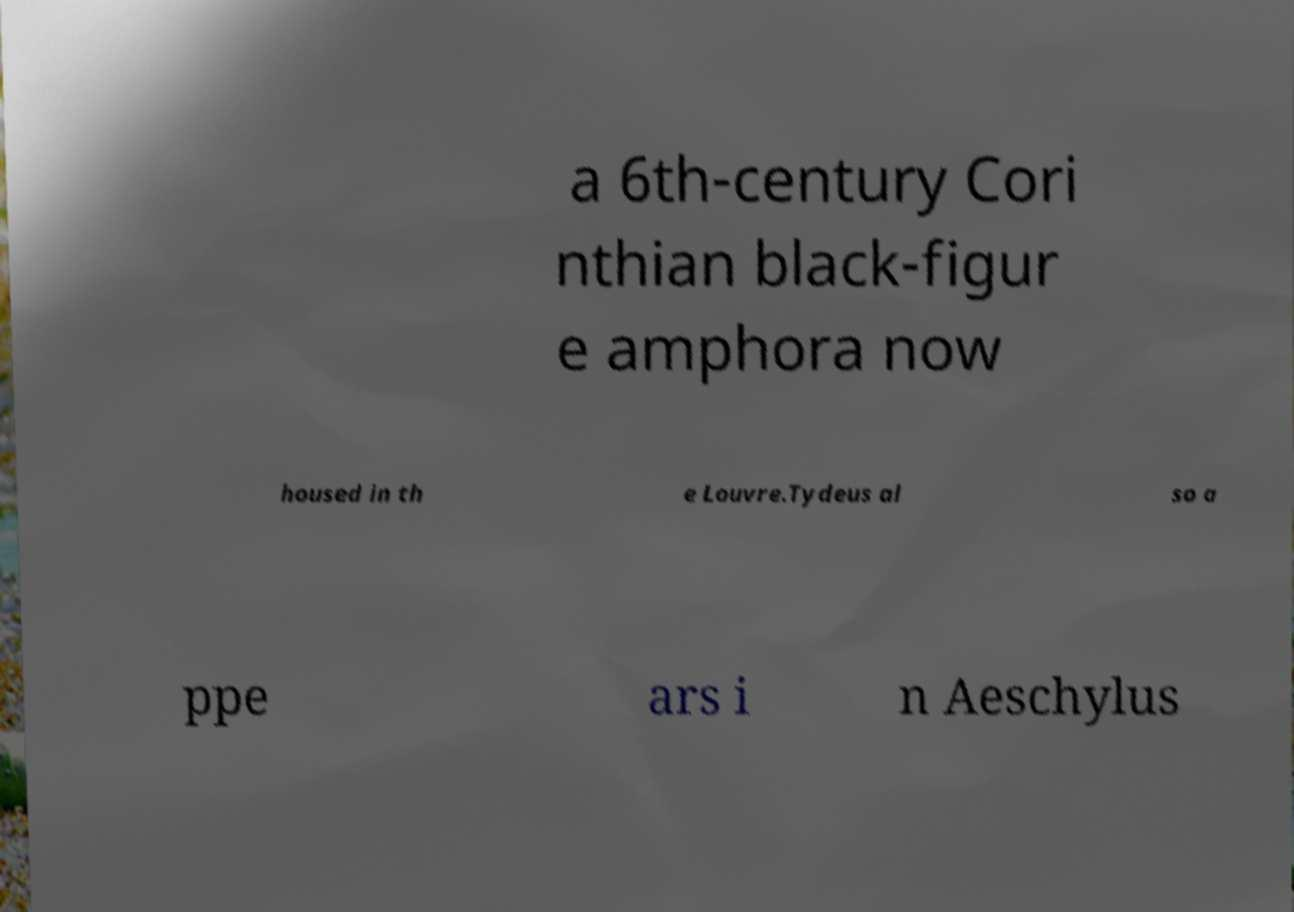For documentation purposes, I need the text within this image transcribed. Could you provide that? a 6th-century Cori nthian black-figur e amphora now housed in th e Louvre.Tydeus al so a ppe ars i n Aeschylus 